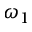<formula> <loc_0><loc_0><loc_500><loc_500>\omega _ { 1 }</formula> 